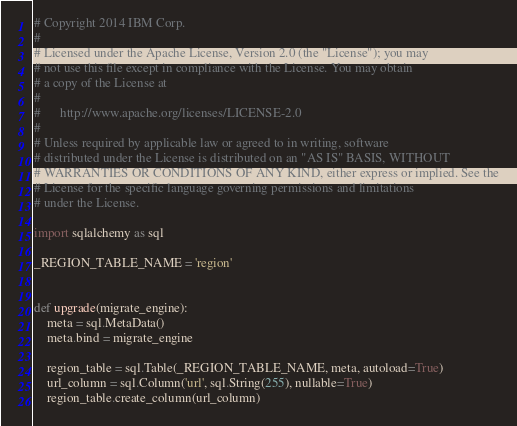Convert code to text. <code><loc_0><loc_0><loc_500><loc_500><_Python_># Copyright 2014 IBM Corp.
#
# Licensed under the Apache License, Version 2.0 (the "License"); you may
# not use this file except in compliance with the License. You may obtain
# a copy of the License at
#
#      http://www.apache.org/licenses/LICENSE-2.0
#
# Unless required by applicable law or agreed to in writing, software
# distributed under the License is distributed on an "AS IS" BASIS, WITHOUT
# WARRANTIES OR CONDITIONS OF ANY KIND, either express or implied. See the
# License for the specific language governing permissions and limitations
# under the License.

import sqlalchemy as sql

_REGION_TABLE_NAME = 'region'


def upgrade(migrate_engine):
    meta = sql.MetaData()
    meta.bind = migrate_engine

    region_table = sql.Table(_REGION_TABLE_NAME, meta, autoload=True)
    url_column = sql.Column('url', sql.String(255), nullable=True)
    region_table.create_column(url_column)
</code> 